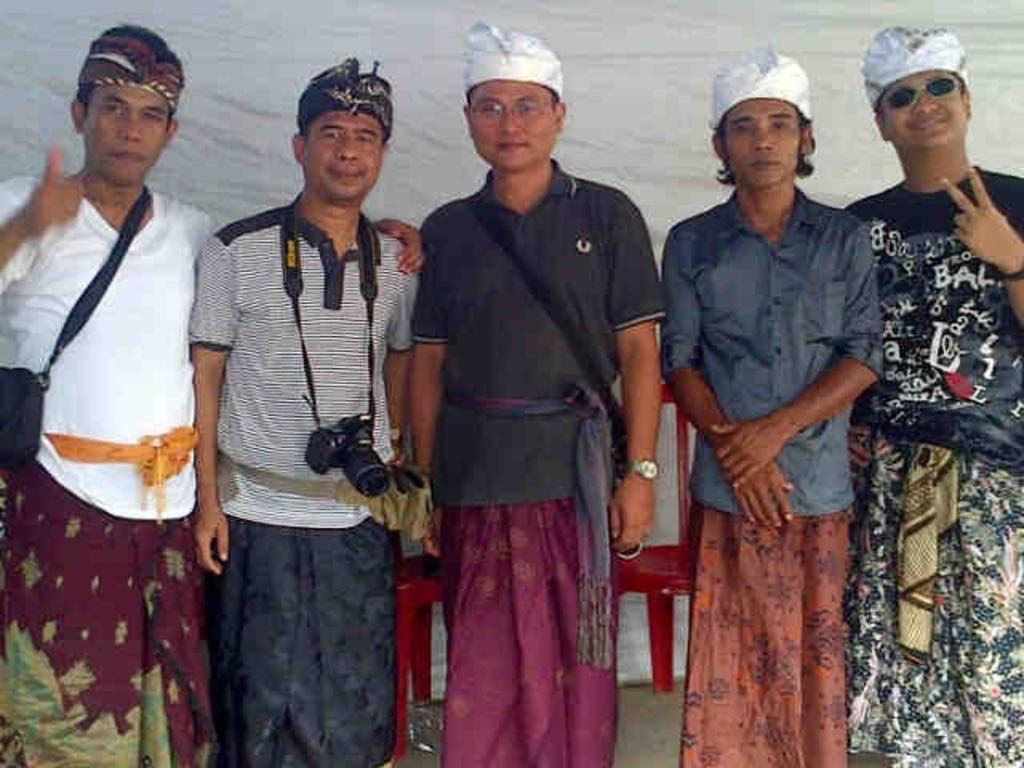Please provide a concise description of this image. In this picture we can see some people are standing and taking picture. 